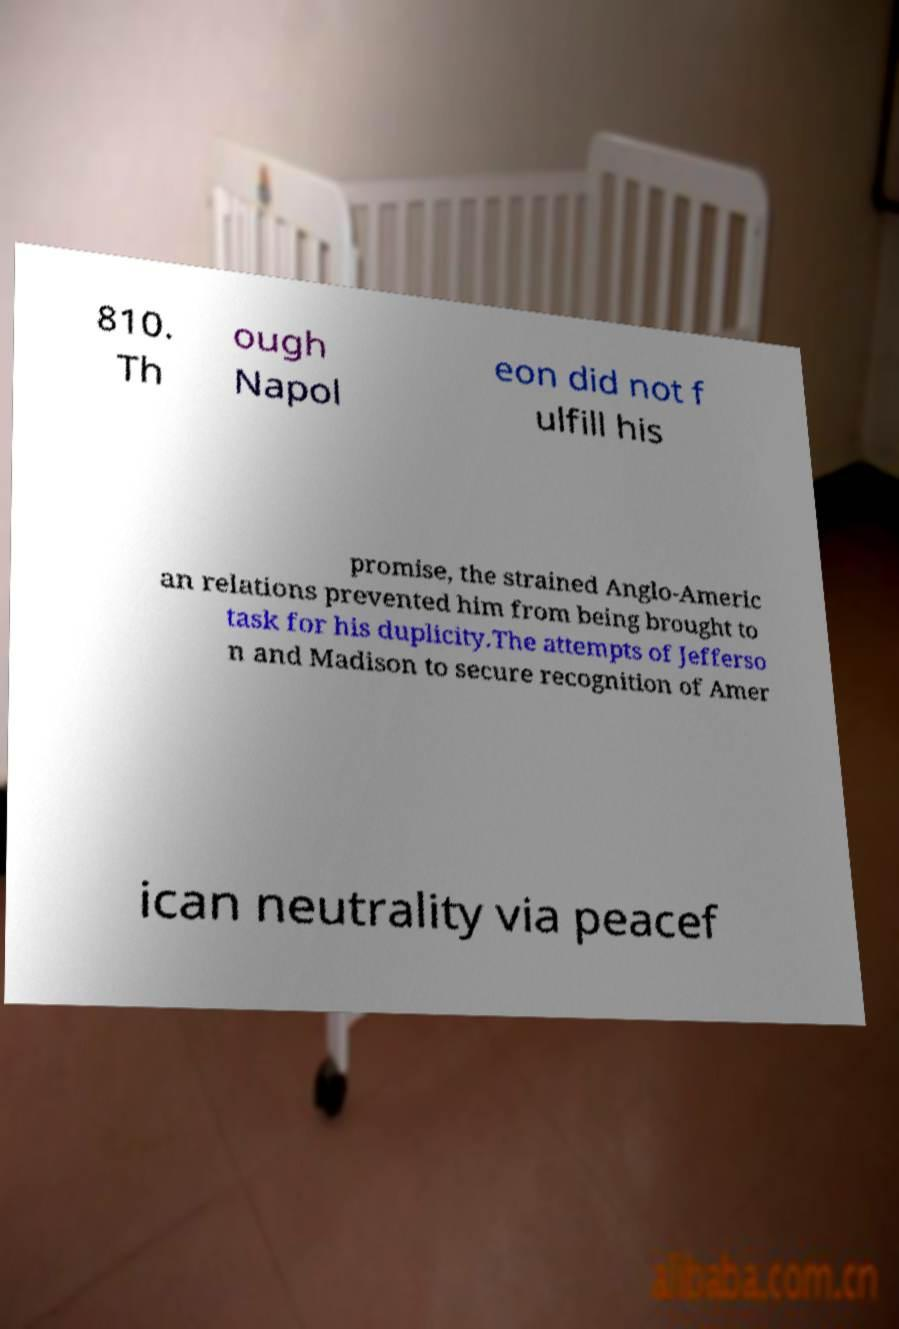Could you extract and type out the text from this image? 810. Th ough Napol eon did not f ulfill his promise, the strained Anglo-Americ an relations prevented him from being brought to task for his duplicity.The attempts of Jefferso n and Madison to secure recognition of Amer ican neutrality via peacef 